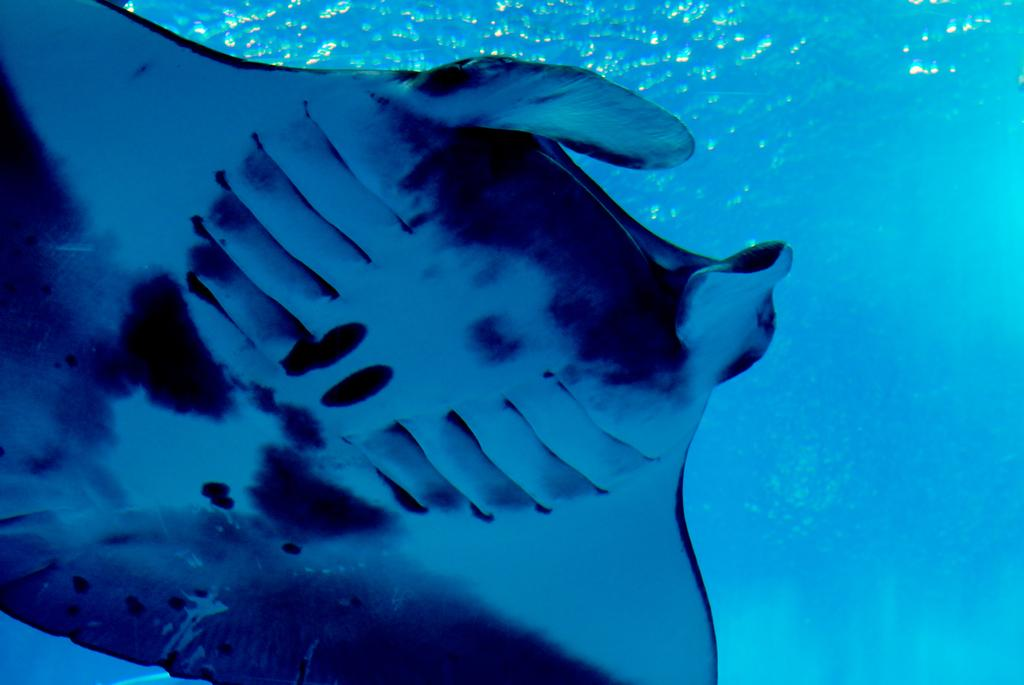What type of animal can be seen in the water in the image? There is a manta ray in the water in the image. How many steps can be seen leading up to the manta ray in the image? There are no steps present in the image; it features a manta ray in the water. What type of bird is swimming alongside the manta ray in the image? There are no birds present in the image; it features a manta ray in the water. 